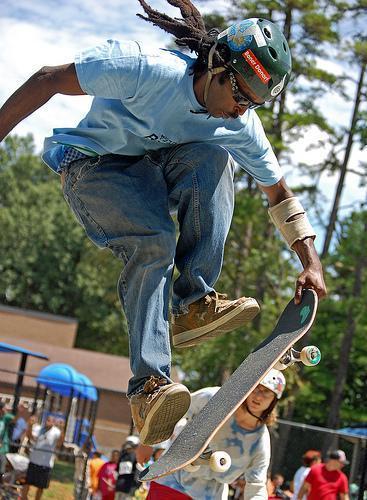How many skateboards are there?
Give a very brief answer. 1. 